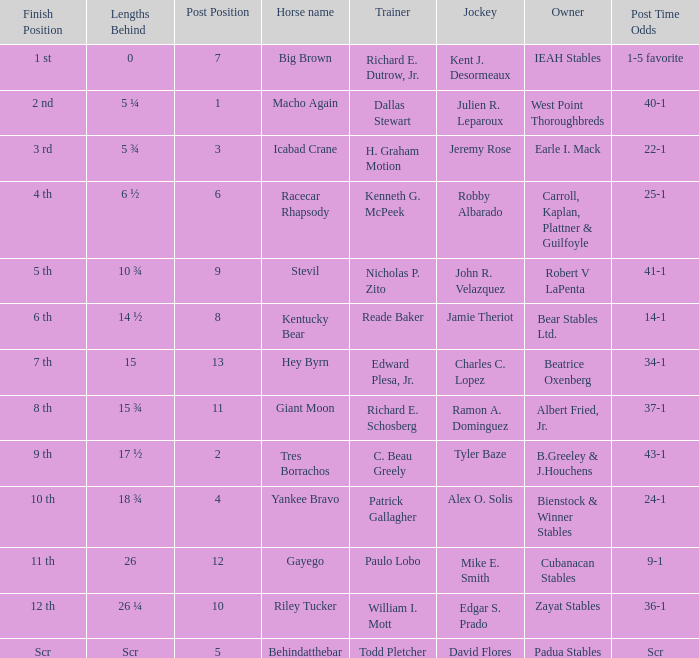Who is the owner of Icabad Crane? Earle I. Mack. 